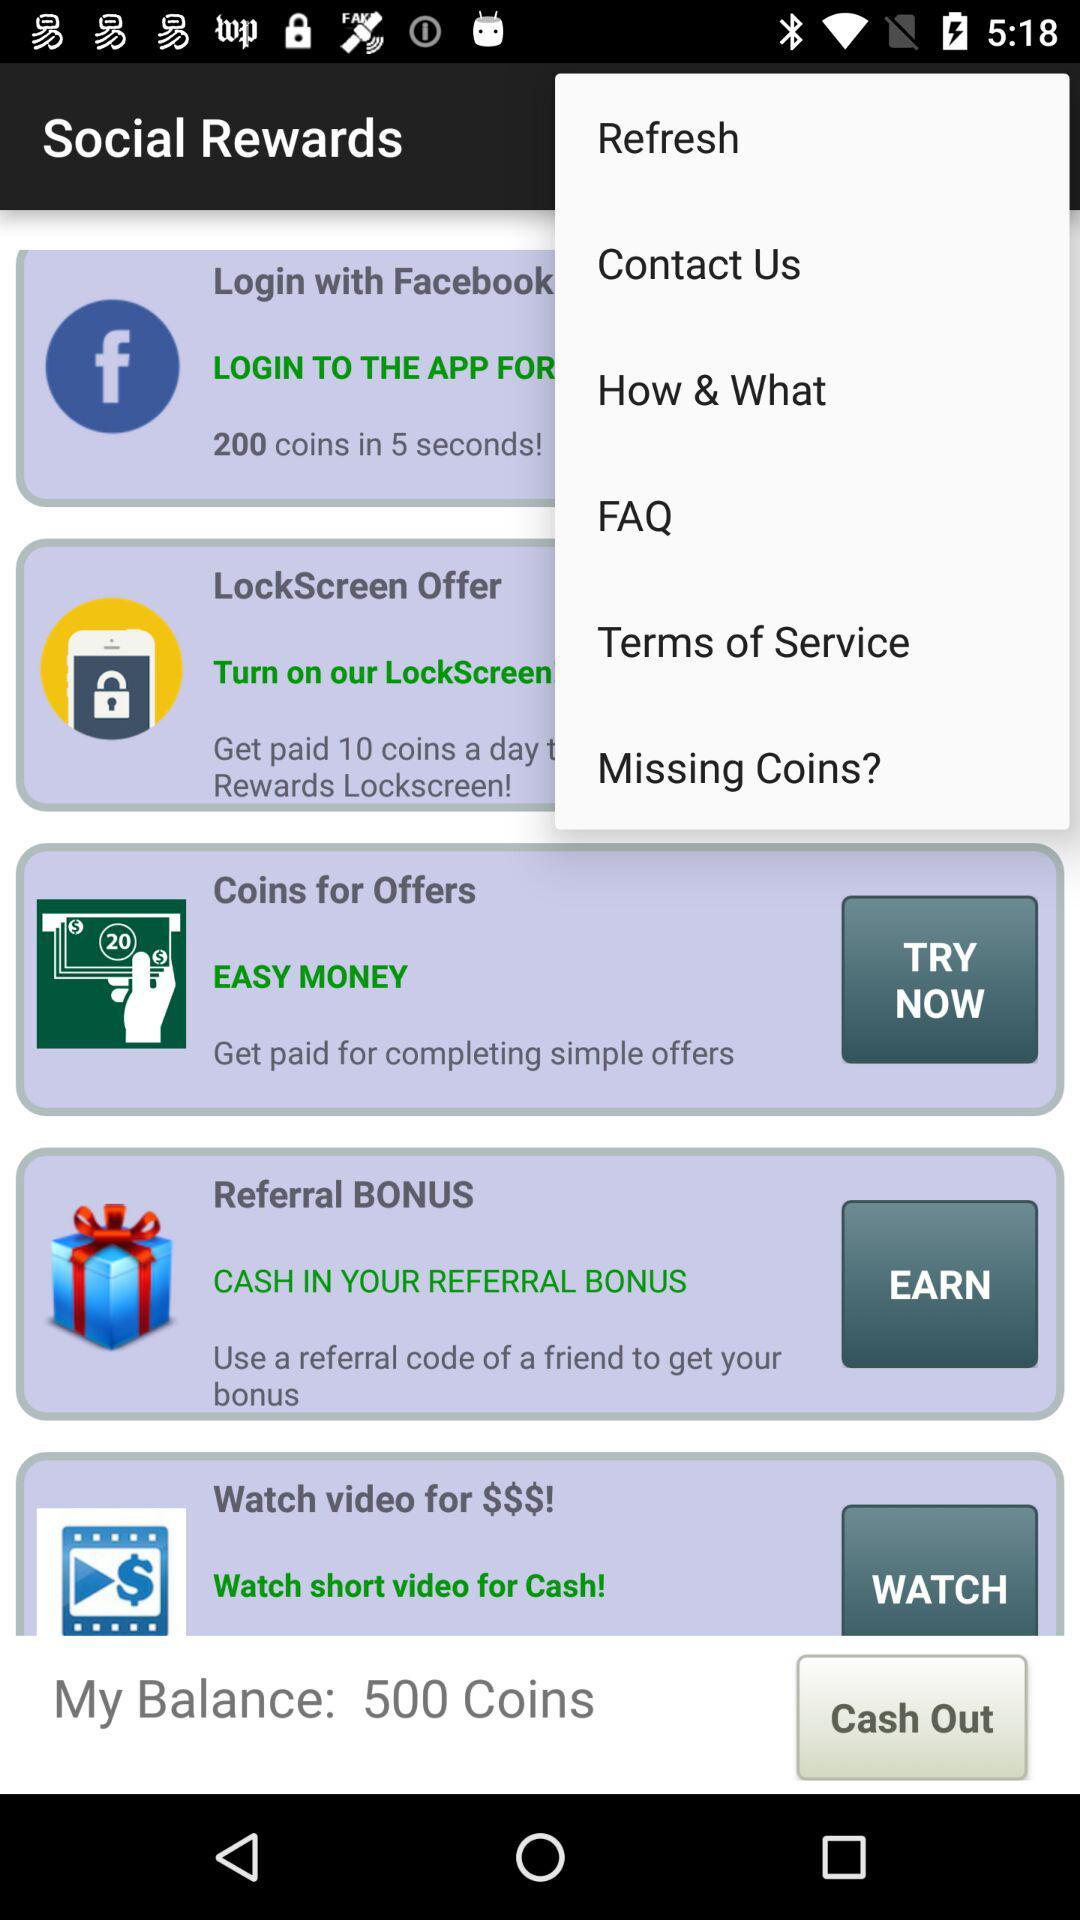How many coins are in "My Balance"? There are 500 coins in "My Balance". 